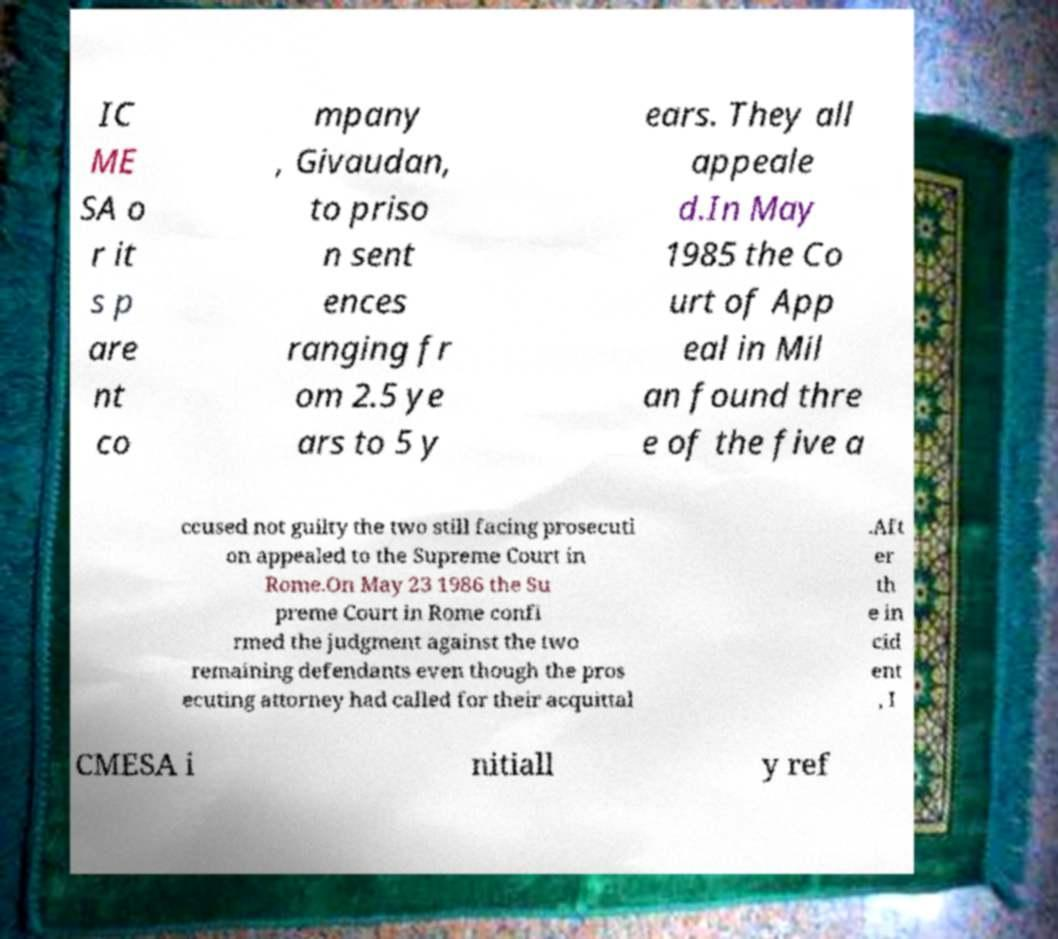Could you extract and type out the text from this image? IC ME SA o r it s p are nt co mpany , Givaudan, to priso n sent ences ranging fr om 2.5 ye ars to 5 y ears. They all appeale d.In May 1985 the Co urt of App eal in Mil an found thre e of the five a ccused not guilty the two still facing prosecuti on appealed to the Supreme Court in Rome.On May 23 1986 the Su preme Court in Rome confi rmed the judgment against the two remaining defendants even though the pros ecuting attorney had called for their acquittal .Aft er th e in cid ent , I CMESA i nitiall y ref 